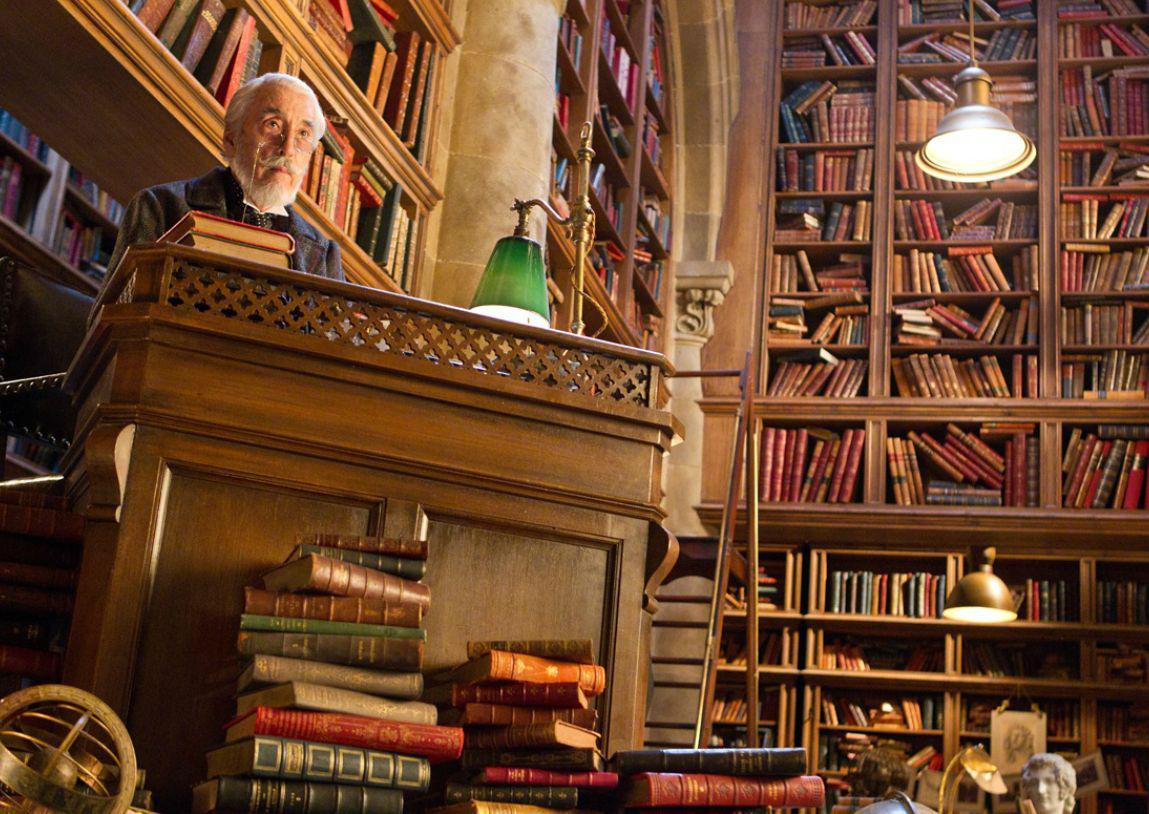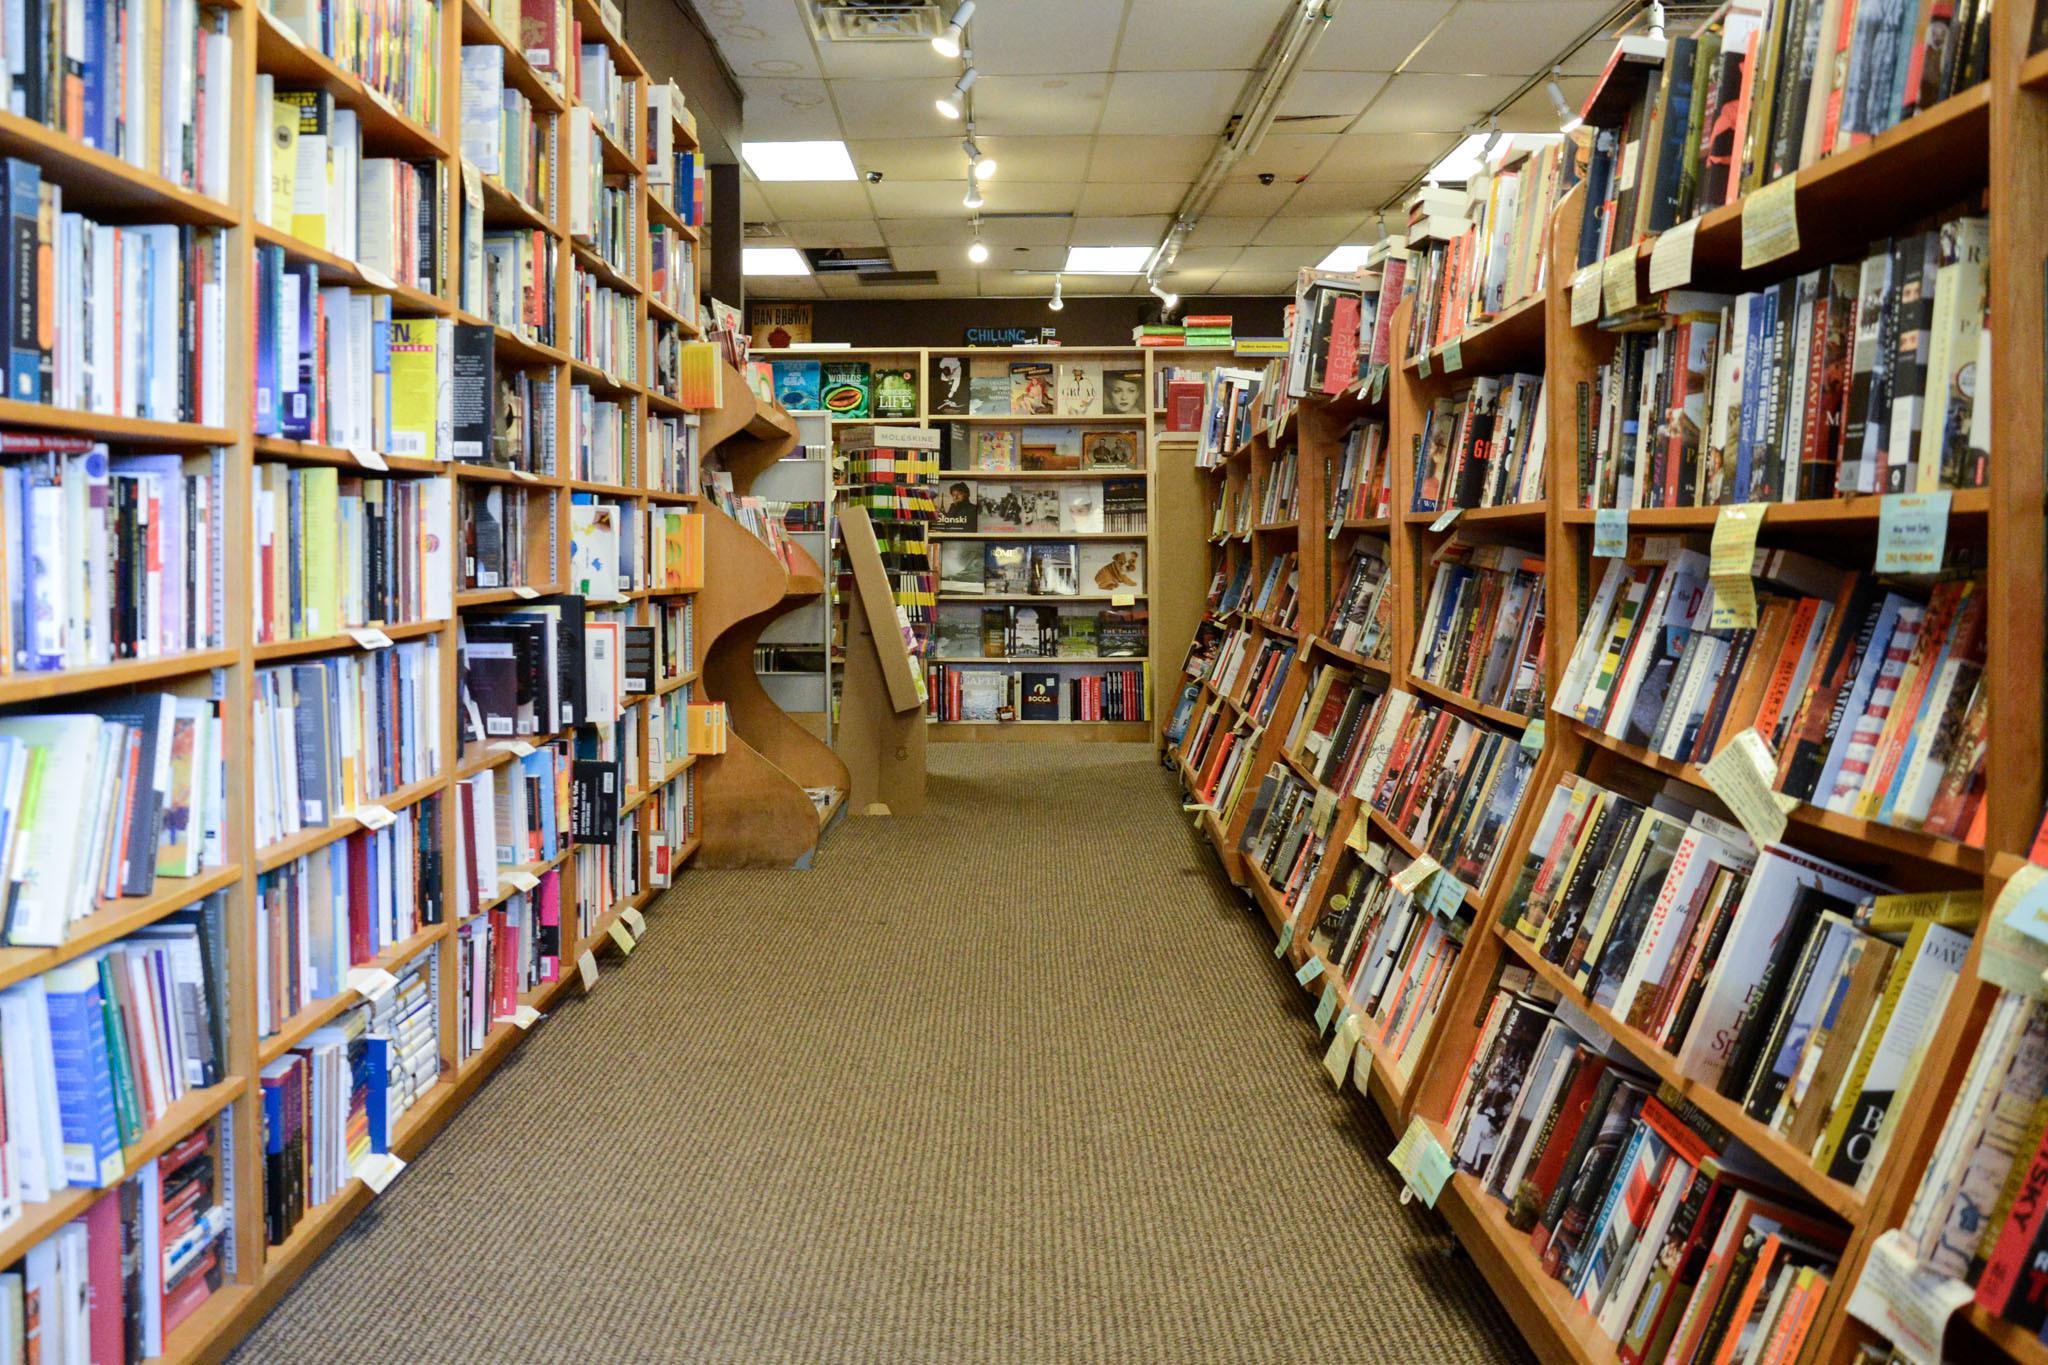The first image is the image on the left, the second image is the image on the right. Evaluate the accuracy of this statement regarding the images: "The right image has visible windows, the left does not.". Is it true? Answer yes or no. No. The first image is the image on the left, the second image is the image on the right. Evaluate the accuracy of this statement regarding the images: "There is at least one person looking at books on a shelf.". Is it true? Answer yes or no. No. 